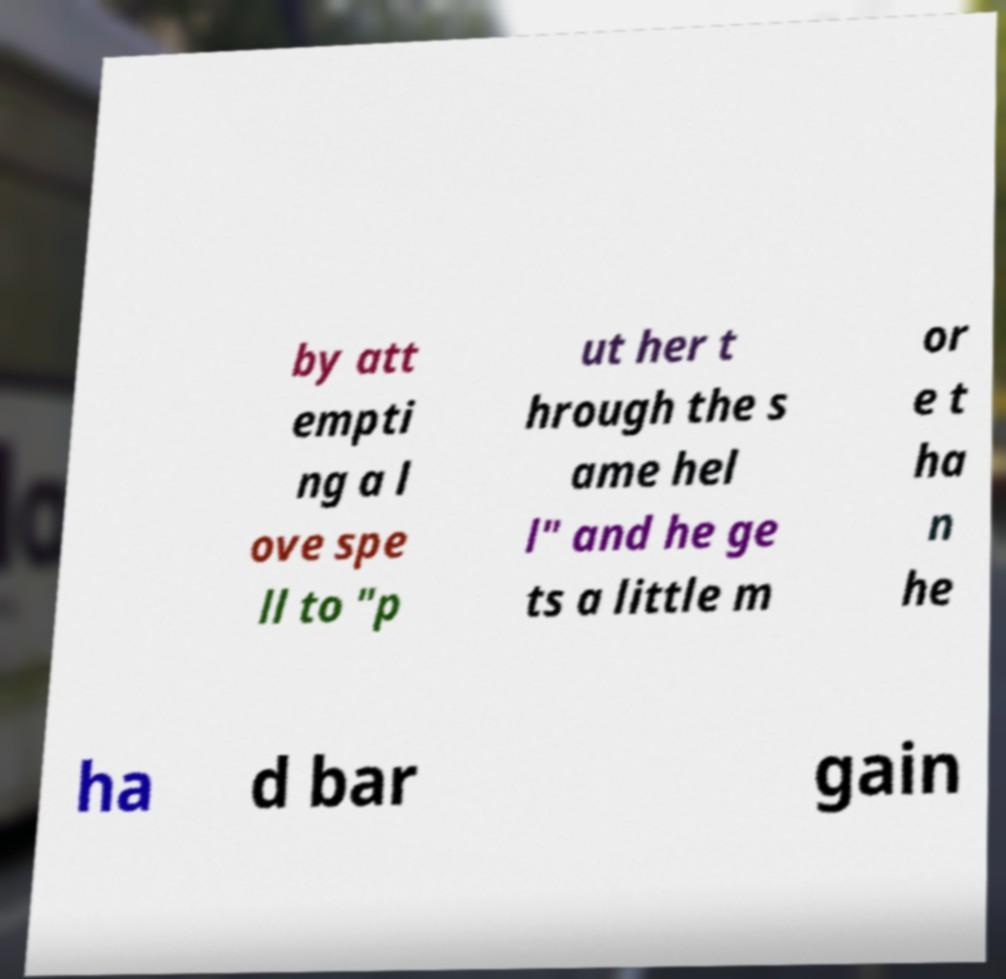What messages or text are displayed in this image? I need them in a readable, typed format. by att empti ng a l ove spe ll to "p ut her t hrough the s ame hel l" and he ge ts a little m or e t ha n he ha d bar gain 